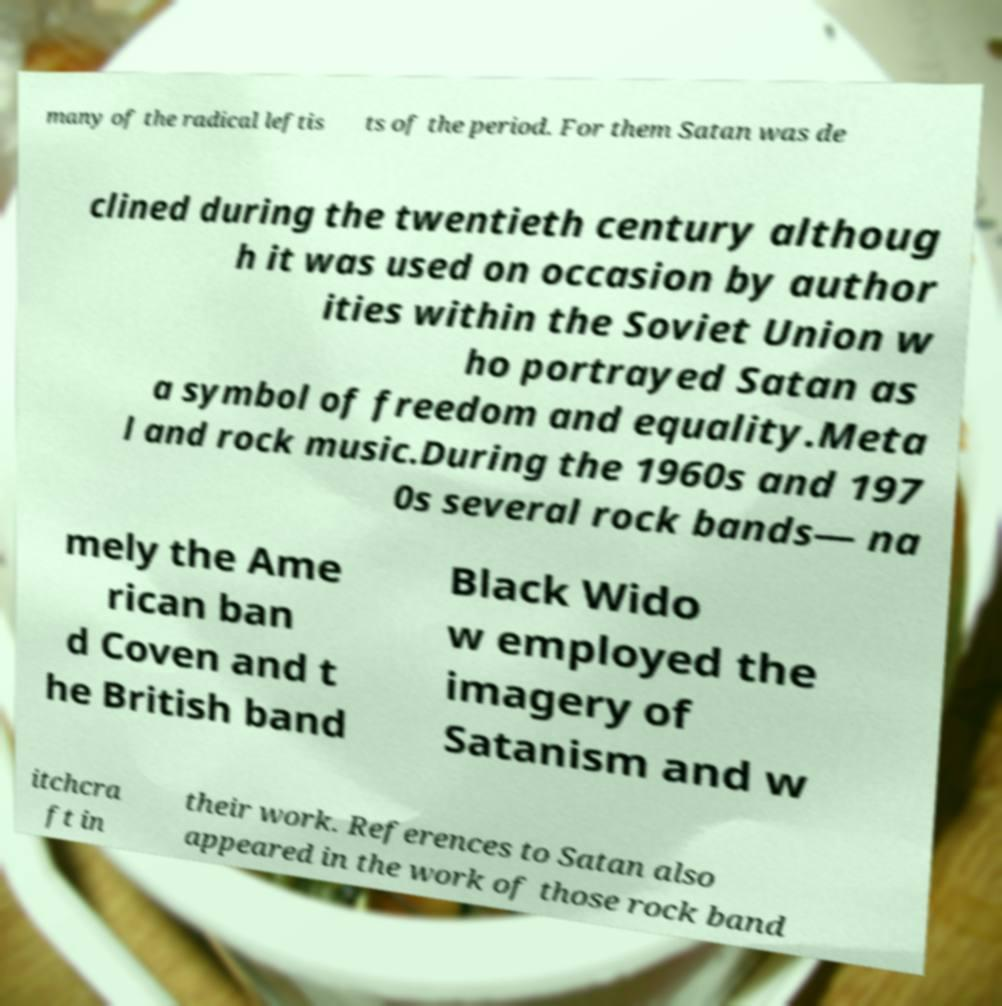Please read and relay the text visible in this image. What does it say? many of the radical leftis ts of the period. For them Satan was de clined during the twentieth century althoug h it was used on occasion by author ities within the Soviet Union w ho portrayed Satan as a symbol of freedom and equality.Meta l and rock music.During the 1960s and 197 0s several rock bands— na mely the Ame rican ban d Coven and t he British band Black Wido w employed the imagery of Satanism and w itchcra ft in their work. References to Satan also appeared in the work of those rock band 